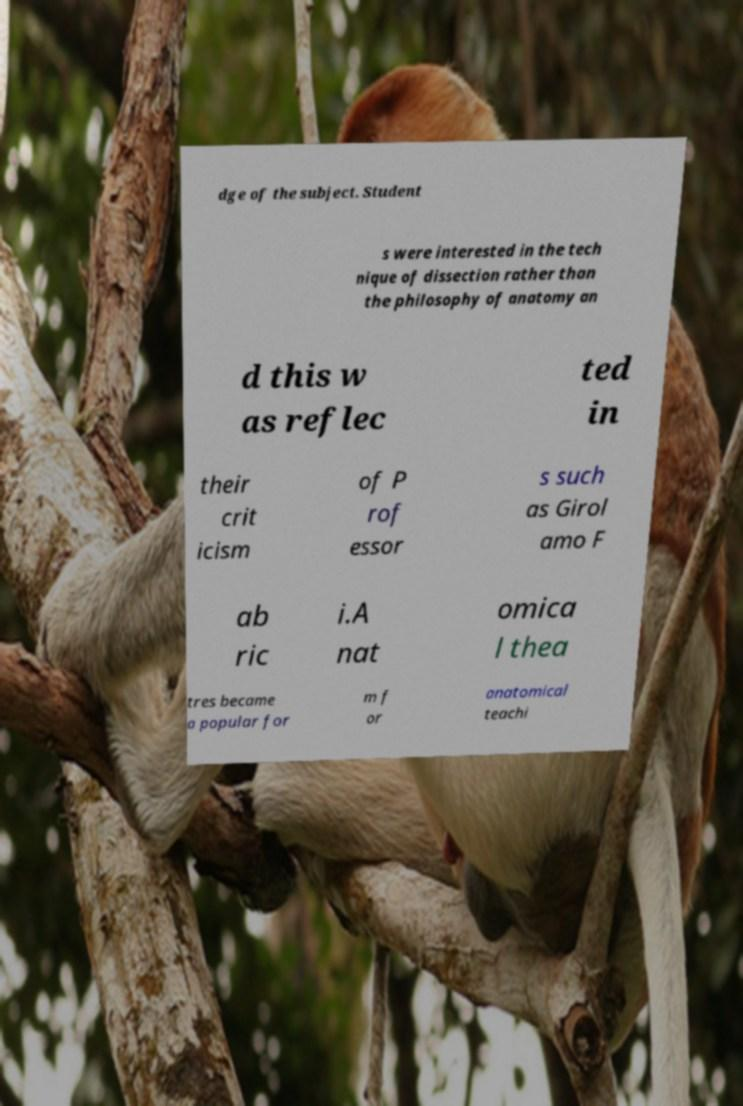Please identify and transcribe the text found in this image. dge of the subject. Student s were interested in the tech nique of dissection rather than the philosophy of anatomy an d this w as reflec ted in their crit icism of P rof essor s such as Girol amo F ab ric i.A nat omica l thea tres became a popular for m f or anatomical teachi 